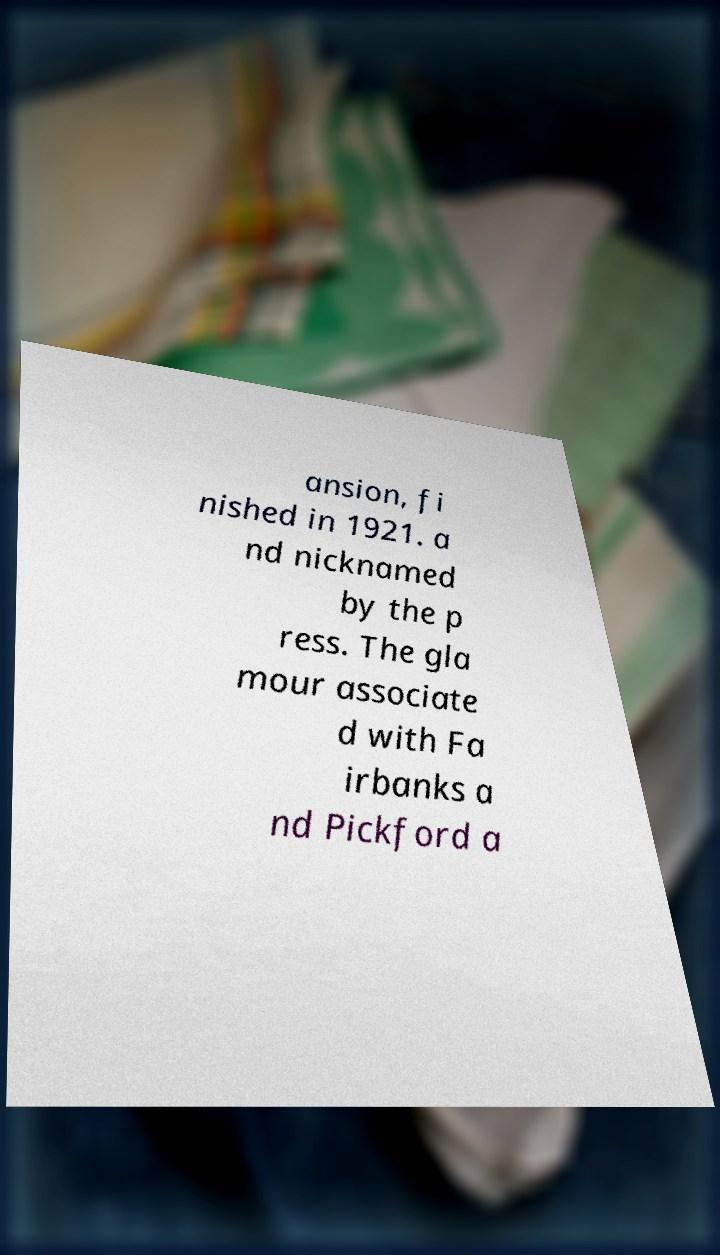Please identify and transcribe the text found in this image. ansion, fi nished in 1921. a nd nicknamed by the p ress. The gla mour associate d with Fa irbanks a nd Pickford a 